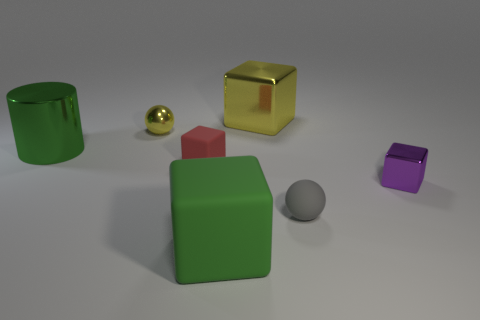Can you describe the lighting conditions in the scene? The scene is well-lit with diffuse, ambient lighting, suggesting an overcast sky or soft-box lighting in a studio. There are no harsh shadows or bright highlights, which indicates the light source is large and probably not very close to the objects. 